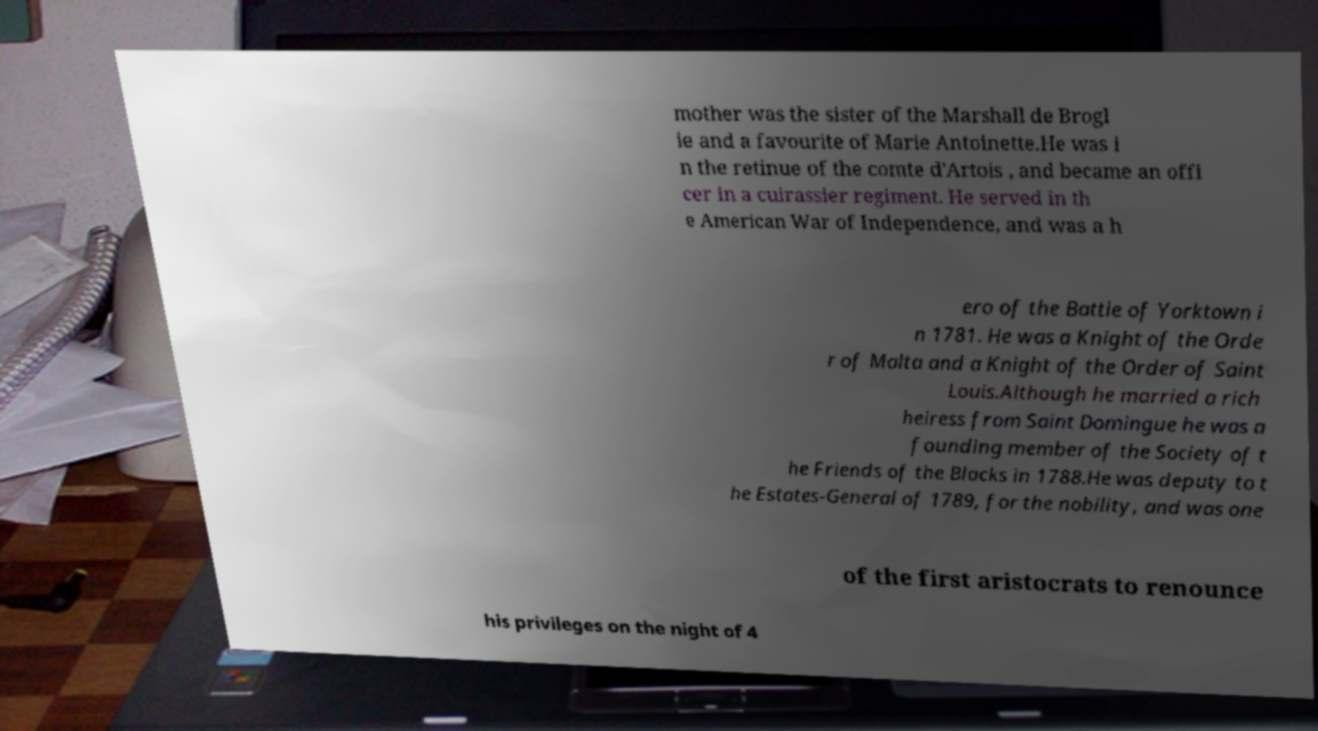There's text embedded in this image that I need extracted. Can you transcribe it verbatim? mother was the sister of the Marshall de Brogl ie and a favourite of Marie Antoinette.He was i n the retinue of the comte d'Artois , and became an offi cer in a cuirassier regiment. He served in th e American War of Independence, and was a h ero of the Battle of Yorktown i n 1781. He was a Knight of the Orde r of Malta and a Knight of the Order of Saint Louis.Although he married a rich heiress from Saint Domingue he was a founding member of the Society of t he Friends of the Blacks in 1788.He was deputy to t he Estates-General of 1789, for the nobility, and was one of the first aristocrats to renounce his privileges on the night of 4 